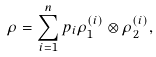Convert formula to latex. <formula><loc_0><loc_0><loc_500><loc_500>\rho = \sum _ { i = 1 } ^ { n } p _ { i } \rho _ { 1 } ^ { ( i ) } \otimes \rho _ { 2 } ^ { ( i ) } ,</formula> 